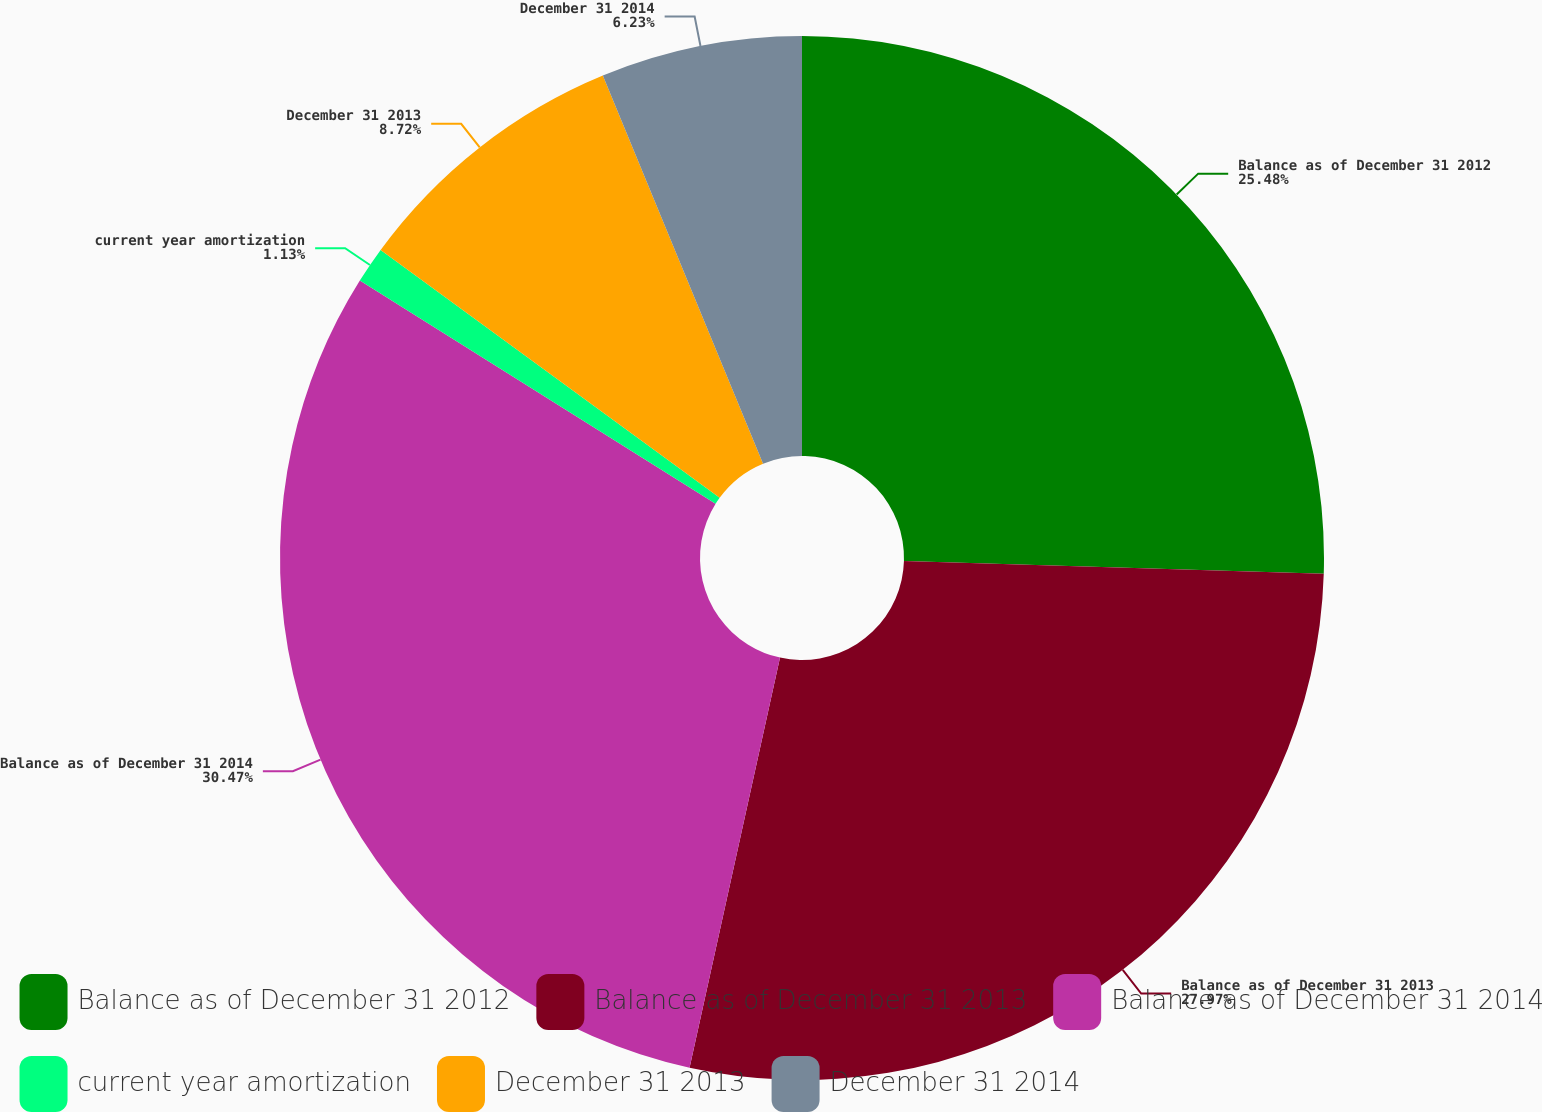Convert chart. <chart><loc_0><loc_0><loc_500><loc_500><pie_chart><fcel>Balance as of December 31 2012<fcel>Balance as of December 31 2013<fcel>Balance as of December 31 2014<fcel>current year amortization<fcel>December 31 2013<fcel>December 31 2014<nl><fcel>25.48%<fcel>27.97%<fcel>30.46%<fcel>1.13%<fcel>8.72%<fcel>6.23%<nl></chart> 